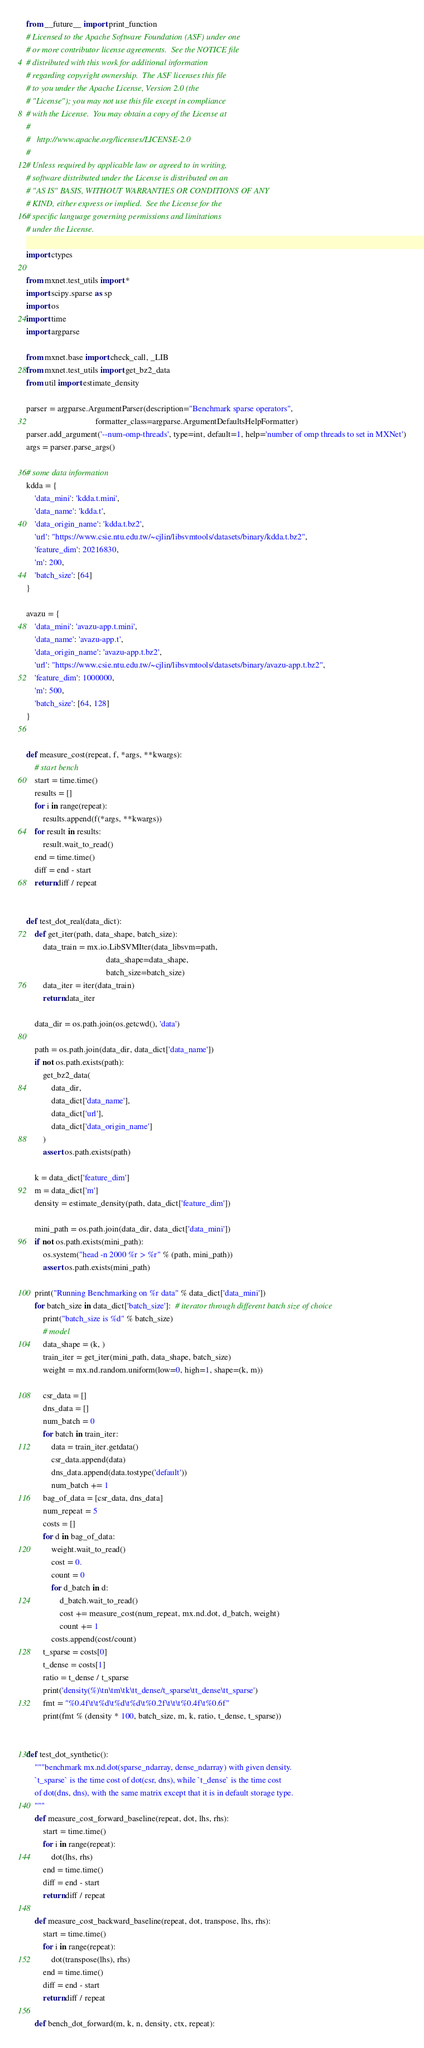<code> <loc_0><loc_0><loc_500><loc_500><_Python_>from __future__ import print_function
# Licensed to the Apache Software Foundation (ASF) under one
# or more contributor license agreements.  See the NOTICE file
# distributed with this work for additional information
# regarding copyright ownership.  The ASF licenses this file
# to you under the Apache License, Version 2.0 (the
# "License"); you may not use this file except in compliance
# with the License.  You may obtain a copy of the License at
#
#   http://www.apache.org/licenses/LICENSE-2.0
#
# Unless required by applicable law or agreed to in writing,
# software distributed under the License is distributed on an
# "AS IS" BASIS, WITHOUT WARRANTIES OR CONDITIONS OF ANY
# KIND, either express or implied.  See the License for the
# specific language governing permissions and limitations
# under the License.

import ctypes

from mxnet.test_utils import *
import scipy.sparse as sp
import os
import time
import argparse

from mxnet.base import check_call, _LIB
from mxnet.test_utils import get_bz2_data
from util import estimate_density

parser = argparse.ArgumentParser(description="Benchmark sparse operators",
                                 formatter_class=argparse.ArgumentDefaultsHelpFormatter)
parser.add_argument('--num-omp-threads', type=int, default=1, help='number of omp threads to set in MXNet')
args = parser.parse_args()

# some data information
kdda = {
    'data_mini': 'kdda.t.mini',
    'data_name': 'kdda.t',
    'data_origin_name': 'kdda.t.bz2',
    'url': "https://www.csie.ntu.edu.tw/~cjlin/libsvmtools/datasets/binary/kdda.t.bz2",
    'feature_dim': 20216830,
    'm': 200,
    'batch_size': [64]
}

avazu = {
    'data_mini': 'avazu-app.t.mini',
    'data_name': 'avazu-app.t',
    'data_origin_name': 'avazu-app.t.bz2',
    'url': "https://www.csie.ntu.edu.tw/~cjlin/libsvmtools/datasets/binary/avazu-app.t.bz2",
    'feature_dim': 1000000,
    'm': 500,
    'batch_size': [64, 128]
}


def measure_cost(repeat, f, *args, **kwargs):
    # start bench
    start = time.time()
    results = []
    for i in range(repeat):
        results.append(f(*args, **kwargs))
    for result in results:
        result.wait_to_read()
    end = time.time()
    diff = end - start
    return diff / repeat


def test_dot_real(data_dict):
    def get_iter(path, data_shape, batch_size):
        data_train = mx.io.LibSVMIter(data_libsvm=path,
                                      data_shape=data_shape,
                                      batch_size=batch_size)
        data_iter = iter(data_train)
        return data_iter

    data_dir = os.path.join(os.getcwd(), 'data')

    path = os.path.join(data_dir, data_dict['data_name'])
    if not os.path.exists(path):
        get_bz2_data(
            data_dir,
            data_dict['data_name'],
            data_dict['url'],
            data_dict['data_origin_name']
        )
        assert os.path.exists(path)

    k = data_dict['feature_dim']
    m = data_dict['m']
    density = estimate_density(path, data_dict['feature_dim'])

    mini_path = os.path.join(data_dir, data_dict['data_mini'])
    if not os.path.exists(mini_path):
        os.system("head -n 2000 %r > %r" % (path, mini_path))
        assert os.path.exists(mini_path)

    print("Running Benchmarking on %r data" % data_dict['data_mini'])
    for batch_size in data_dict['batch_size']:  # iterator through different batch size of choice
        print("batch_size is %d" % batch_size)
        # model
        data_shape = (k, )
        train_iter = get_iter(mini_path, data_shape, batch_size)
        weight = mx.nd.random.uniform(low=0, high=1, shape=(k, m))

        csr_data = []
        dns_data = []
        num_batch = 0
        for batch in train_iter:
            data = train_iter.getdata()
            csr_data.append(data)
            dns_data.append(data.tostype('default'))
            num_batch += 1
        bag_of_data = [csr_data, dns_data]
        num_repeat = 5
        costs = []
        for d in bag_of_data:
            weight.wait_to_read()
            cost = 0.
            count = 0
            for d_batch in d:
                d_batch.wait_to_read()
                cost += measure_cost(num_repeat, mx.nd.dot, d_batch, weight)
                count += 1
            costs.append(cost/count)
        t_sparse = costs[0]
        t_dense = costs[1]
        ratio = t_dense / t_sparse
        print('density(%)\tn\tm\tk\tt_dense/t_sparse\tt_dense\tt_sparse')
        fmt = "%0.4f\t\t%d\t%d\t%d\t%0.2f\t\t\t%0.4f\t%0.6f"
        print(fmt % (density * 100, batch_size, m, k, ratio, t_dense, t_sparse))


def test_dot_synthetic():
    """benchmark mx.nd.dot(sparse_ndarray, dense_ndarray) with given density.
    `t_sparse` is the time cost of dot(csr, dns), while `t_dense` is the time cost
    of dot(dns, dns), with the same matrix except that it is in default storage type.
    """
    def measure_cost_forward_baseline(repeat, dot, lhs, rhs):
        start = time.time()
        for i in range(repeat):
            dot(lhs, rhs)
        end = time.time()
        diff = end - start
        return diff / repeat

    def measure_cost_backward_baseline(repeat, dot, transpose, lhs, rhs):
        start = time.time()
        for i in range(repeat):
            dot(transpose(lhs), rhs)
        end = time.time()
        diff = end - start
        return diff / repeat

    def bench_dot_forward(m, k, n, density, ctx, repeat):</code> 